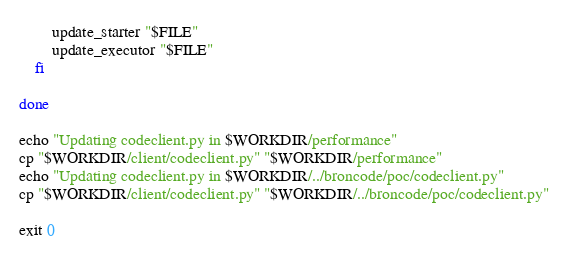<code> <loc_0><loc_0><loc_500><loc_500><_Bash_>        update_starter "$FILE"
        update_executor "$FILE"
    fi

done

echo "Updating codeclient.py in $WORKDIR/performance"
cp "$WORKDIR/client/codeclient.py" "$WORKDIR/performance"
echo "Updating codeclient.py in $WORKDIR/../broncode/poc/codeclient.py"
cp "$WORKDIR/client/codeclient.py" "$WORKDIR/../broncode/poc/codeclient.py"

exit 0</code> 